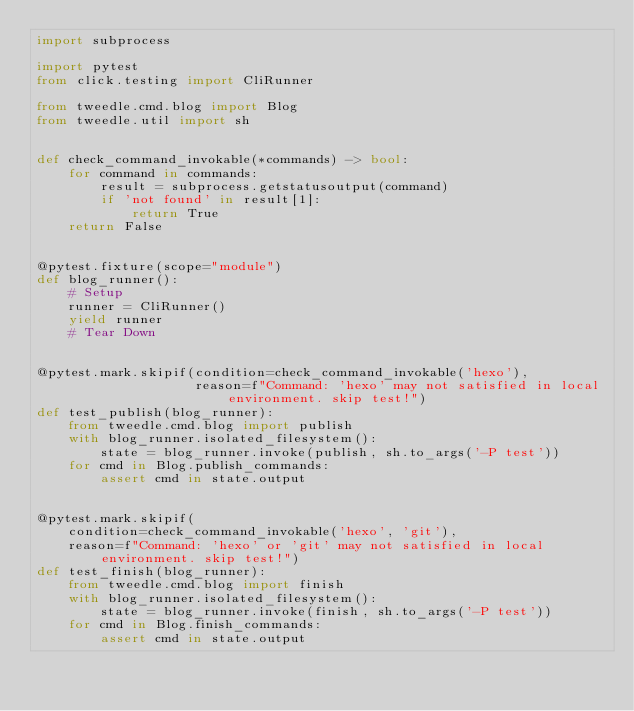<code> <loc_0><loc_0><loc_500><loc_500><_Python_>import subprocess

import pytest
from click.testing import CliRunner

from tweedle.cmd.blog import Blog
from tweedle.util import sh


def check_command_invokable(*commands) -> bool:
    for command in commands:
        result = subprocess.getstatusoutput(command)
        if 'not found' in result[1]:
            return True
    return False


@pytest.fixture(scope="module")
def blog_runner():
    # Setup
    runner = CliRunner()
    yield runner
    # Tear Down


@pytest.mark.skipif(condition=check_command_invokable('hexo'),
                    reason=f"Command: 'hexo' may not satisfied in local environment. skip test!")
def test_publish(blog_runner):
    from tweedle.cmd.blog import publish
    with blog_runner.isolated_filesystem():
        state = blog_runner.invoke(publish, sh.to_args('-P test'))
    for cmd in Blog.publish_commands:
        assert cmd in state.output


@pytest.mark.skipif(
    condition=check_command_invokable('hexo', 'git'),
    reason=f"Command: 'hexo' or 'git' may not satisfied in local environment. skip test!")
def test_finish(blog_runner):
    from tweedle.cmd.blog import finish
    with blog_runner.isolated_filesystem():
        state = blog_runner.invoke(finish, sh.to_args('-P test'))
    for cmd in Blog.finish_commands:
        assert cmd in state.output
</code> 